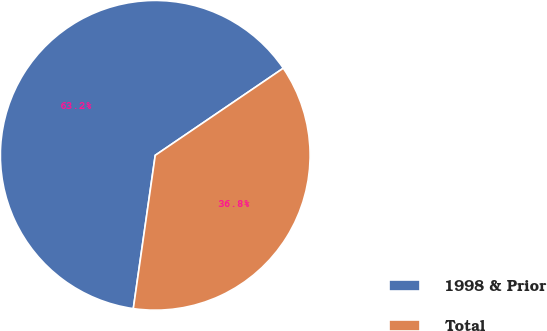Convert chart. <chart><loc_0><loc_0><loc_500><loc_500><pie_chart><fcel>1998 & Prior<fcel>Total<nl><fcel>63.23%<fcel>36.77%<nl></chart> 